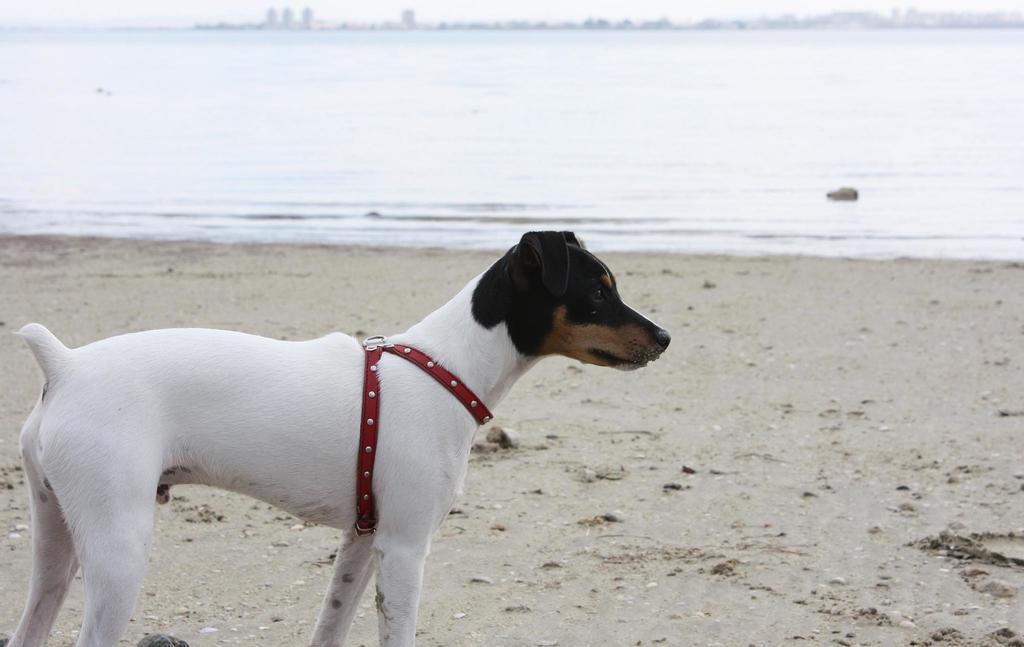What is located in the front of the image? There is a dog and a belt in the front of the image. Can you describe the dog in the image? The dog is in the front of the image, but no specific details about the dog are provided in the facts. What can be seen in the background of the image? Water is visible in the background of the image. What type of cheese is being offered in the wilderness in the image? There is no mention of cheese or wilderness in the image, so this question cannot be answered definitively. 